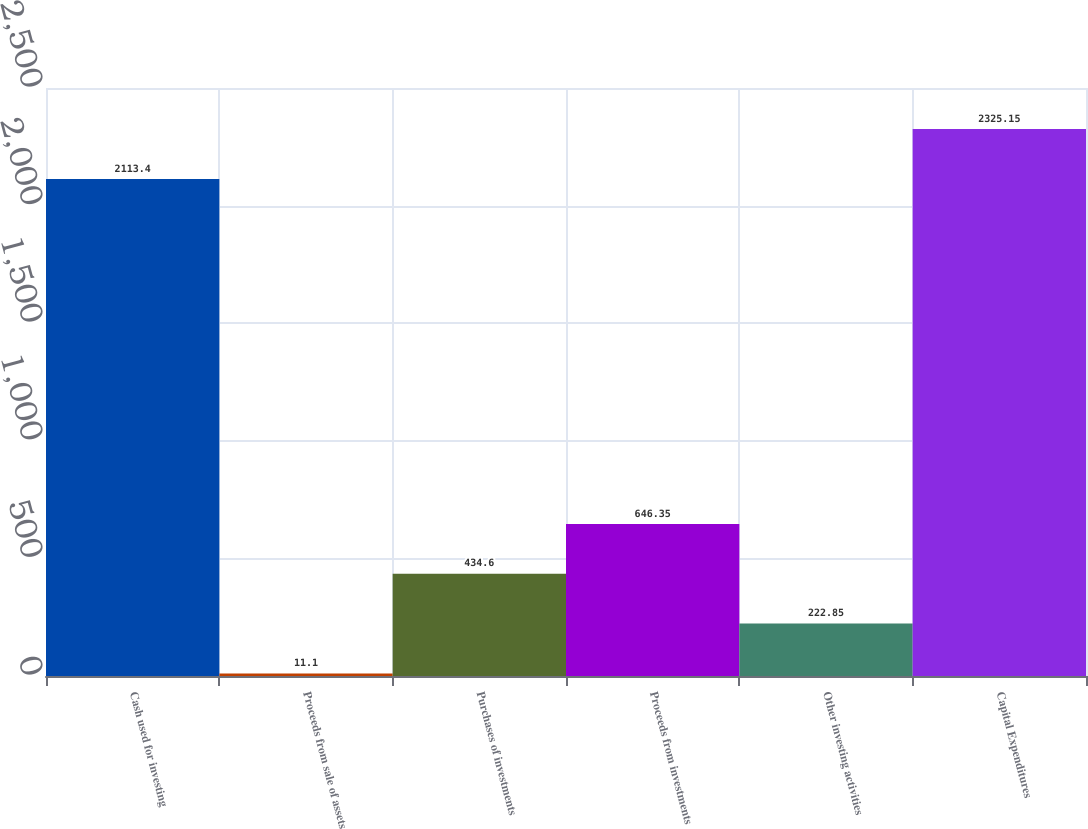<chart> <loc_0><loc_0><loc_500><loc_500><bar_chart><fcel>Cash used for investing<fcel>Proceeds from sale of assets<fcel>Purchases of investments<fcel>Proceeds from investments<fcel>Other investing activities<fcel>Capital Expenditures<nl><fcel>2113.4<fcel>11.1<fcel>434.6<fcel>646.35<fcel>222.85<fcel>2325.15<nl></chart> 